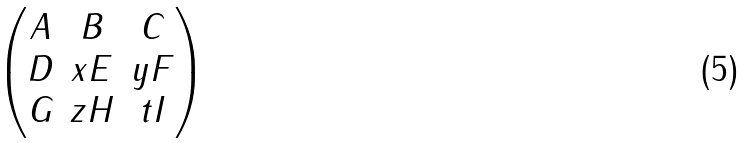<formula> <loc_0><loc_0><loc_500><loc_500>\begin{pmatrix} A & B & C \\ D & x E & y F \\ G & z H & t I \end{pmatrix}</formula> 